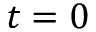Convert formula to latex. <formula><loc_0><loc_0><loc_500><loc_500>t = 0</formula> 